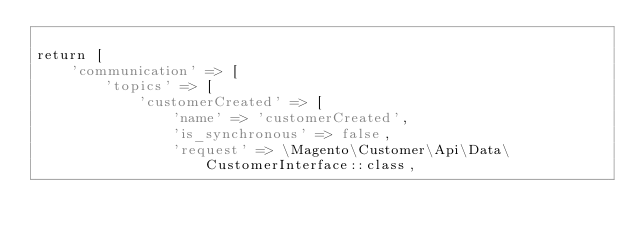<code> <loc_0><loc_0><loc_500><loc_500><_PHP_>
return [
    'communication' => [
        'topics' => [
            'customerCreated' => [
                'name' => 'customerCreated',
                'is_synchronous' => false,
                'request' => \Magento\Customer\Api\Data\CustomerInterface::class,</code> 